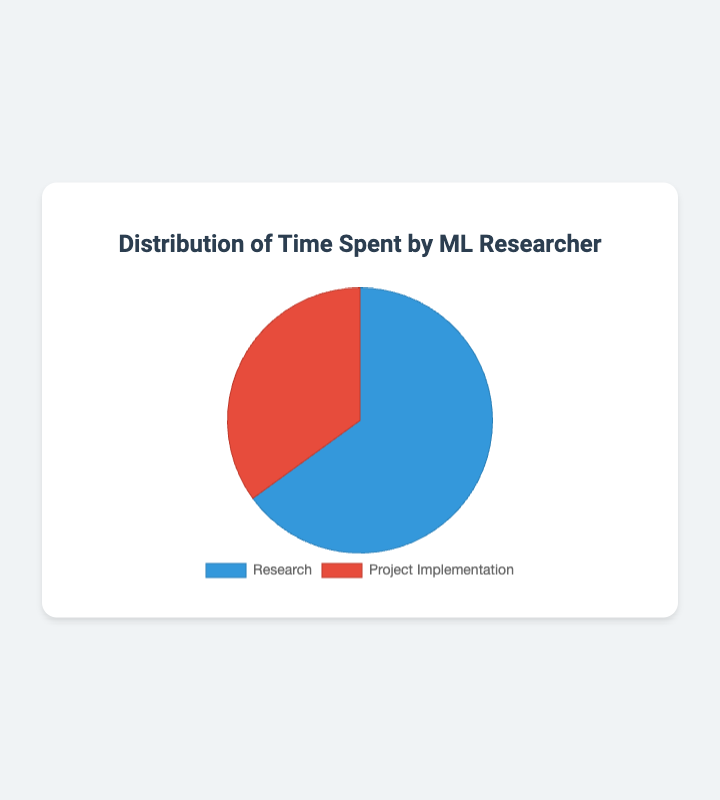What percentage of time is spent on research? The figure indicates that 65% of the time is spent on research.
Answer: 65% What percentage of time is spent on project implementation? The chart shows that 35% of the time is allocated to project implementation.
Answer: 35% Which activity takes up more time in a typical day for a machine learning researcher? Comparing the two slices of the pie chart, research takes up more time (65%) compared to project implementation (35%).
Answer: Research How much more time is spent on research compared to project implementation? To find how much more time is spent on research, subtract the percentage of time spent on project implementation from the percentage of time spent on research: 65% - 35% = 30%.
Answer: 30% What is the ratio of time spent on research to project implementation? The ratio can be calculated by dividing the percentage of time spent on research by the percentage of time spent on project implementation: 65 / 35 = 1.86 (approximately).
Answer: 1.86:1 If a machine learning researcher worked for 8 hours in a day, how many hours are spent on research? To determine the time spent on research in hours, multiply the total working hours by the percentage of time spent on research: (8 hours * 65%) = 5.2 hours.
Answer: 5.2 hours How many hours are spent on project implementation in an 8-hour workday? Multiply the total working hours by the percentage of time spent on project implementation: (8 hours * 35%) = 2.8 hours.
Answer: 2.8 hours What color is used to represent research in the pie chart? The chart uses blue to represent the time spent on research.
Answer: Blue If a machine learning researcher reduces the time spent on research by 10%, what would the new percentage for research and project implementation be? If the time spent on research is reduced by 10%, it would be 65% - 10% = 55%. The project implementation time would increase accordingly to ensure the total is 100%, making it 45%.
Answer: Research: 55%, Project Implementation: 45% 